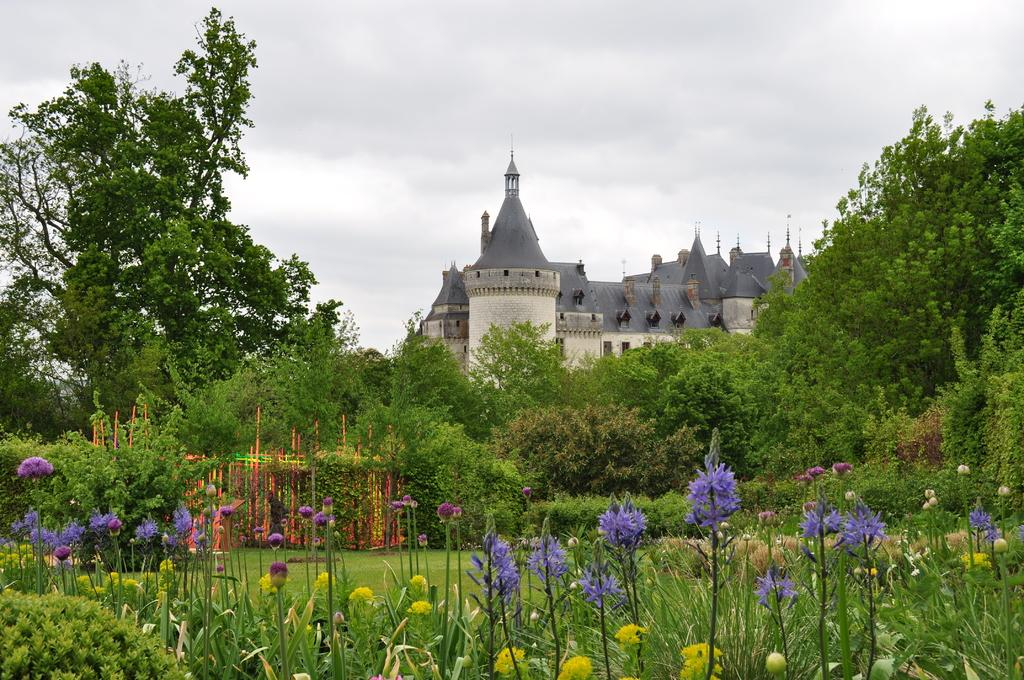What type of vegetation can be seen in the image? There are flowers, grass, and trees in the image. What type of structure is visible in the background of the image? There is a building in the background of the image. What is the condition of the sky in the image? The sky is cloudy in the background of the image. Can you see a toy floating in the water near the dock in the image? There is no dock or water present in the image, so it is not possible to see a toy floating in the water. 